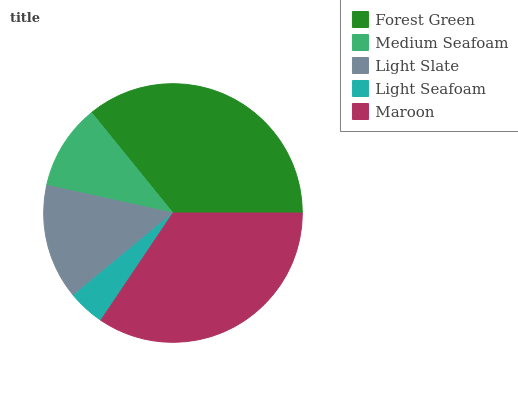Is Light Seafoam the minimum?
Answer yes or no. Yes. Is Forest Green the maximum?
Answer yes or no. Yes. Is Medium Seafoam the minimum?
Answer yes or no. No. Is Medium Seafoam the maximum?
Answer yes or no. No. Is Forest Green greater than Medium Seafoam?
Answer yes or no. Yes. Is Medium Seafoam less than Forest Green?
Answer yes or no. Yes. Is Medium Seafoam greater than Forest Green?
Answer yes or no. No. Is Forest Green less than Medium Seafoam?
Answer yes or no. No. Is Light Slate the high median?
Answer yes or no. Yes. Is Light Slate the low median?
Answer yes or no. Yes. Is Forest Green the high median?
Answer yes or no. No. Is Medium Seafoam the low median?
Answer yes or no. No. 